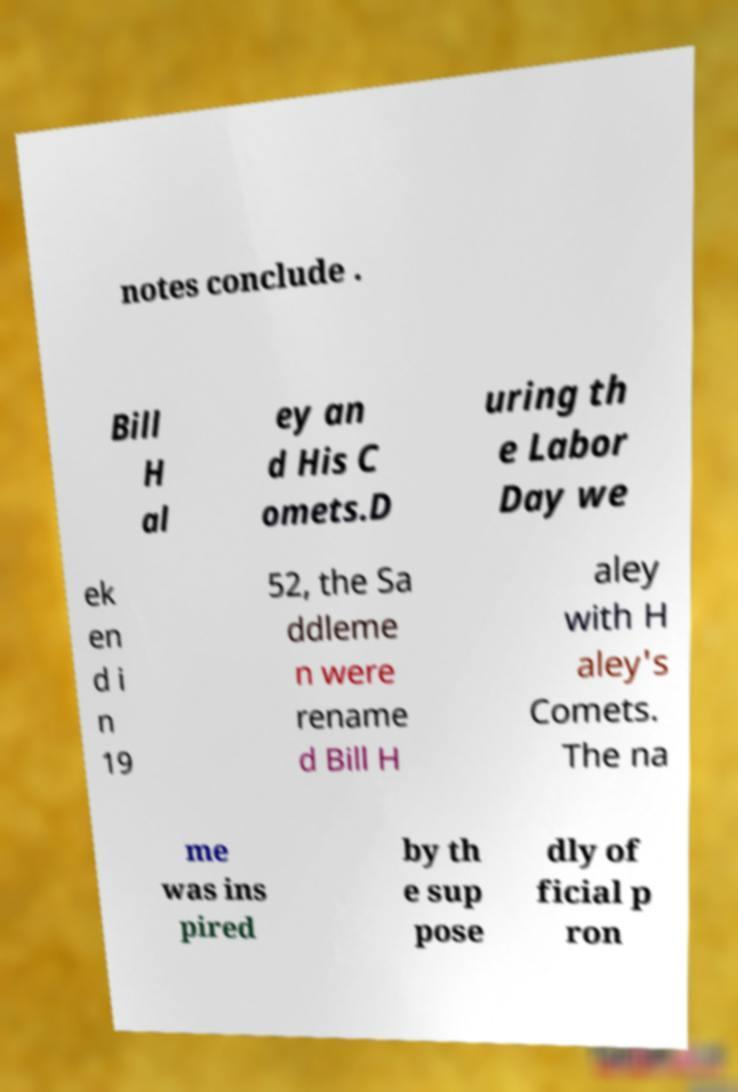Could you assist in decoding the text presented in this image and type it out clearly? notes conclude . Bill H al ey an d His C omets.D uring th e Labor Day we ek en d i n 19 52, the Sa ddleme n were rename d Bill H aley with H aley's Comets. The na me was ins pired by th e sup pose dly of ficial p ron 